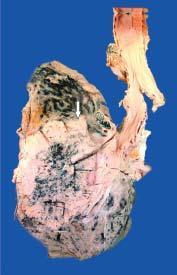s the tumour seen extending directly into adjacent lung parenchyma and hilar nodes?
Answer the question using a single word or phrase. Yes 